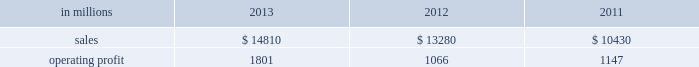Areas exceeding 14.1 million acres ( 5.7 million hectares ) .
Products and brand designations appearing in italics are trademarks of international paper or a related company .
Industry segment results industrial packaging demand for industrial packaging products is closely correlated with non-durable industrial goods production , as well as with demand for processed foods , poultry , meat and agricultural products .
In addition to prices and volumes , major factors affecting the profitability of industrial packaging are raw material and energy costs , freight costs , manufacturing efficiency and product mix .
Industrial packaging net sales and operating profits include the results of the temple-inland packaging operations from the date of acquisition in february 2012 and the results of the brazil packaging business from the date of acquisition in january 2013 .
In addition , due to the acquisition of a majority share of olmuksa international paper sabanci ambalaj sanayi ve ticaret a.s. , ( now called olmuksan international paper or olmuksan ) net sales for our corrugated packaging business in turkey are included in the business segment totals beginning in the first quarter of 2013 and the operating profits reflect a higher ownership percentage than in previous years .
Net sales for 2013 increased 12% ( 12 % ) to $ 14.8 billion compared with $ 13.3 billion in 2012 , and 42% ( 42 % ) compared with $ 10.4 billion in 2011 .
Operating profits were 69% ( 69 % ) higher in 2013 than in 2012 and 57% ( 57 % ) higher than in 2011 .
Excluding costs associated with the acquisition and integration of temple-inland , the divestiture of three containerboard mills and other special items , operating profits in 2013 were 36% ( 36 % ) higher than in 2012 and 59% ( 59 % ) higher than in 2011 .
Benefits from the net impact of higher average sales price realizations and an unfavorable mix ( $ 749 million ) were offset by lower sales volumes ( $ 73 million ) , higher operating costs ( $ 64 million ) , higher maintenance outage costs ( $ 16 million ) and higher input costs ( $ 102 million ) .
Additionally , operating profits in 2013 include costs of $ 62 million associated with the integration of temple-inland , a gain of $ 13 million related to a bargain purchase adjustment on the acquisition of a majority share of our operations in turkey , and a net gain of $ 1 million for other items , while operating profits in 2012 included costs of $ 184 million associated with the acquisition and integration of temple-inland , mill divestiture costs of $ 91 million , costs associated with the restructuring of our european packaging business of $ 17 million and a $ 3 million gain for other items .
Industrial packaging .
North american industrial packaging net sales were $ 12.5 billion in 2013 compared with $ 11.6 billion in 2012 and $ 8.6 billion in 2011 .
Operating profits in 2013 were $ 1.8 billion ( both including and excluding costs associated with the integration of temple-inland and other special items ) compared with $ 1.0 billion ( $ 1.3 billion excluding costs associated with the acquisition and integration of temple-inland and mill divestiture costs ) in 2012 and $ 1.1 billion ( both including and excluding costs associated with signing an agreement to acquire temple-inland ) in 2011 .
Sales volumes decreased in 2013 compared with 2012 reflecting flat demand for boxes and the impact of commercial decisions .
Average sales price realizations were significantly higher mainly due to the realization of price increases for domestic containerboard and boxes .
Input costs were higher for wood , energy and recycled fiber .
Freight costs also increased .
Planned maintenance downtime costs were higher than in 2012 .
Manufacturing operating costs decreased , but were offset by inflation and higher overhead and distribution costs .
The business took about 850000 tons of total downtime in 2013 of which about 450000 were market- related and 400000 were maintenance downtime .
In 2012 , the business took about 945000 tons of total downtime of which about 580000 were market-related and about 365000 were maintenance downtime .
Operating profits in 2013 included $ 62 million of costs associated with the integration of temple-inland .
Operating profits in 2012 included $ 184 million of costs associated with the acquisition and integration of temple-inland and $ 91 million of costs associated with the divestiture of three containerboard mills .
Looking ahead to 2014 , compared with the fourth quarter of 2013 , sales volumes in the first quarter are expected to increase for boxes due to a higher number of shipping days offset by the impact from the severe winter weather events impacting much of the u.s .
Input costs are expected to be higher for energy , recycled fiber , wood and starch .
Planned maintenance downtime spending is expected to be about $ 51 million higher with outages scheduled at six mills compared with four mills in the 2013 fourth quarter .
Manufacturing operating costs are expected to be lower .
However , operating profits will be negatively impacted by the adverse winter weather in the first quarter of 2014 .
Emea industrial packaging net sales in 2013 include the sales of our packaging operations in turkey which are now fully consolidated .
Net sales were $ 1.3 billion in 2013 compared with $ 1.0 billion in 2012 and $ 1.1 billion in 2011 .
Operating profits in 2013 were $ 43 million ( $ 32 .
What percentage of industrial packaging sales where represented by north american industrial packaging net sales in 2013? 
Computations: ((12.5 * 1000) / 14810)
Answer: 0.84402. 